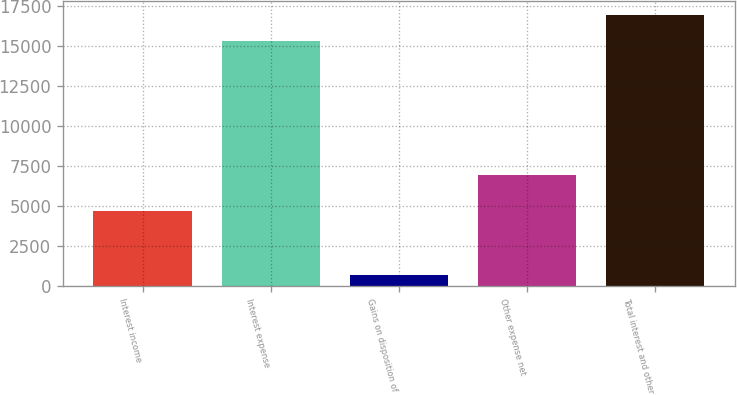Convert chart. <chart><loc_0><loc_0><loc_500><loc_500><bar_chart><fcel>Interest income<fcel>Interest expense<fcel>Gains on disposition of<fcel>Other expense net<fcel>Total interest and other<nl><fcel>4688<fcel>15325<fcel>697<fcel>6937<fcel>16943<nl></chart> 